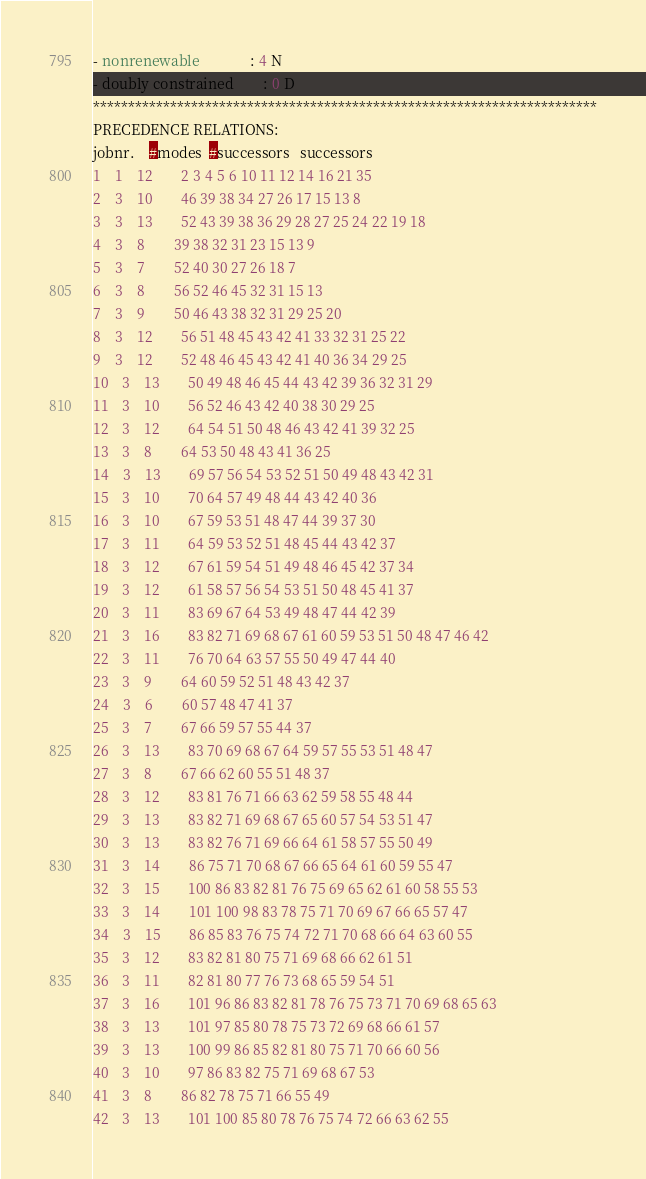<code> <loc_0><loc_0><loc_500><loc_500><_ObjectiveC_>- nonrenewable              : 4 N
- doubly constrained        : 0 D
************************************************************************
PRECEDENCE RELATIONS:
jobnr.    #modes  #successors   successors
1	1	12		2 3 4 5 6 10 11 12 14 16 21 35 
2	3	10		46 39 38 34 27 26 17 15 13 8 
3	3	13		52 43 39 38 36 29 28 27 25 24 22 19 18 
4	3	8		39 38 32 31 23 15 13 9 
5	3	7		52 40 30 27 26 18 7 
6	3	8		56 52 46 45 32 31 15 13 
7	3	9		50 46 43 38 32 31 29 25 20 
8	3	12		56 51 48 45 43 42 41 33 32 31 25 22 
9	3	12		52 48 46 45 43 42 41 40 36 34 29 25 
10	3	13		50 49 48 46 45 44 43 42 39 36 32 31 29 
11	3	10		56 52 46 43 42 40 38 30 29 25 
12	3	12		64 54 51 50 48 46 43 42 41 39 32 25 
13	3	8		64 53 50 48 43 41 36 25 
14	3	13		69 57 56 54 53 52 51 50 49 48 43 42 31 
15	3	10		70 64 57 49 48 44 43 42 40 36 
16	3	10		67 59 53 51 48 47 44 39 37 30 
17	3	11		64 59 53 52 51 48 45 44 43 42 37 
18	3	12		67 61 59 54 51 49 48 46 45 42 37 34 
19	3	12		61 58 57 56 54 53 51 50 48 45 41 37 
20	3	11		83 69 67 64 53 49 48 47 44 42 39 
21	3	16		83 82 71 69 68 67 61 60 59 53 51 50 48 47 46 42 
22	3	11		76 70 64 63 57 55 50 49 47 44 40 
23	3	9		64 60 59 52 51 48 43 42 37 
24	3	6		60 57 48 47 41 37 
25	3	7		67 66 59 57 55 44 37 
26	3	13		83 70 69 68 67 64 59 57 55 53 51 48 47 
27	3	8		67 66 62 60 55 51 48 37 
28	3	12		83 81 76 71 66 63 62 59 58 55 48 44 
29	3	13		83 82 71 69 68 67 65 60 57 54 53 51 47 
30	3	13		83 82 76 71 69 66 64 61 58 57 55 50 49 
31	3	14		86 75 71 70 68 67 66 65 64 61 60 59 55 47 
32	3	15		100 86 83 82 81 76 75 69 65 62 61 60 58 55 53 
33	3	14		101 100 98 83 78 75 71 70 69 67 66 65 57 47 
34	3	15		86 85 83 76 75 74 72 71 70 68 66 64 63 60 55 
35	3	12		83 82 81 80 75 71 69 68 66 62 61 51 
36	3	11		82 81 80 77 76 73 68 65 59 54 51 
37	3	16		101 96 86 83 82 81 78 76 75 73 71 70 69 68 65 63 
38	3	13		101 97 85 80 78 75 73 72 69 68 66 61 57 
39	3	13		100 99 86 85 82 81 80 75 71 70 66 60 56 
40	3	10		97 86 83 82 75 71 69 68 67 53 
41	3	8		86 82 78 75 71 66 55 49 
42	3	13		101 100 85 80 78 76 75 74 72 66 63 62 55 </code> 